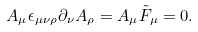<formula> <loc_0><loc_0><loc_500><loc_500>A _ { \mu } \epsilon _ { \mu \nu \rho } \partial _ { \nu } A _ { \rho } = A _ { \mu } { \tilde { F } } _ { \mu } = 0 .</formula> 